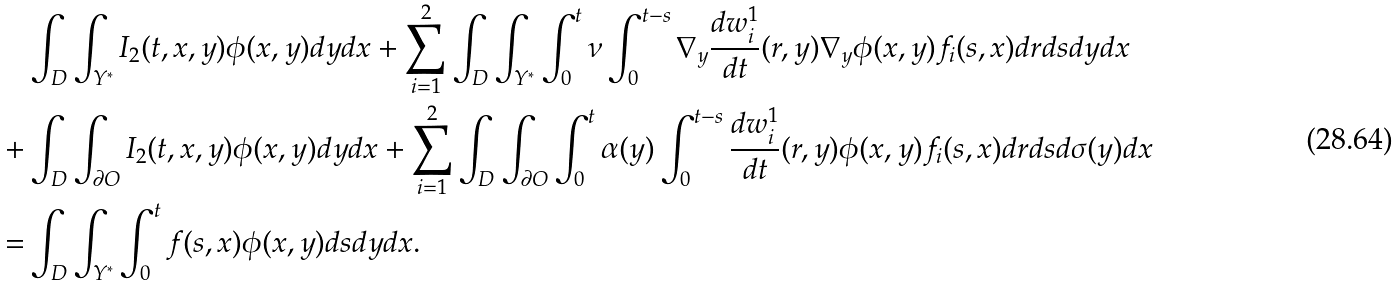Convert formula to latex. <formula><loc_0><loc_0><loc_500><loc_500>& \int _ { D } \int _ { Y ^ { * } } I _ { 2 } ( t , x , y ) \phi ( x , y ) d y d x + \sum _ { i = 1 } ^ { 2 } \int _ { D } \int _ { Y ^ { * } } \int _ { 0 } ^ { t } \nu \int _ { 0 } ^ { t - s } \nabla _ { y } \frac { d w _ { i } ^ { 1 } } { d t } ( r , y ) \nabla _ { y } \phi ( x , y ) f _ { i } ( s , x ) d r d s d y d x \\ + & \int _ { D } \int _ { \partial O } I _ { 2 } ( t , x , y ) \phi ( x , y ) d y d x + \sum _ { i = 1 } ^ { 2 } \int _ { D } \int _ { \partial O } \int _ { 0 } ^ { t } \alpha ( y ) \int _ { 0 } ^ { t - s } \frac { d w _ { i } ^ { 1 } } { d t } ( r , y ) \phi ( x , y ) f _ { i } ( s , x ) d r d s d \sigma ( y ) d x \\ = & \int _ { D } \int _ { Y ^ { * } } \int _ { 0 } ^ { t } f ( s , x ) \phi ( x , y ) d s d y d x .</formula> 